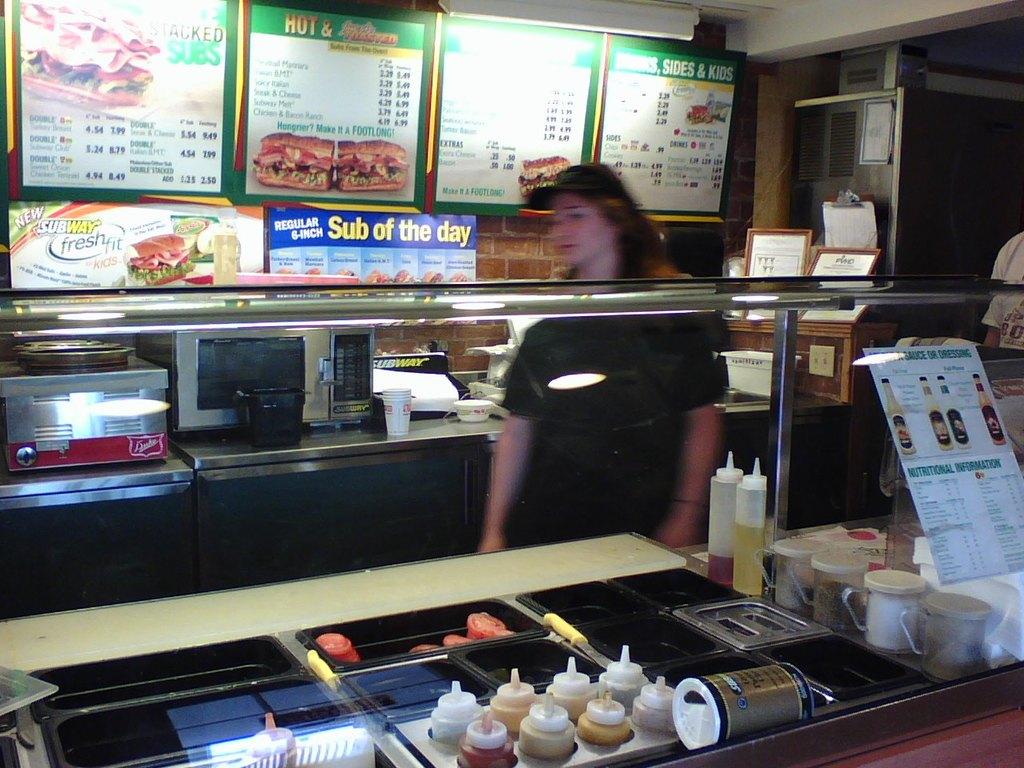What fast food place is this?
Keep it short and to the point. Subway. What is the sub of the day?
Make the answer very short. Regular 6 inch. 